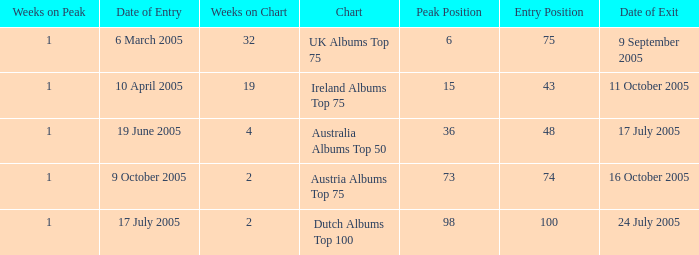Would you be able to parse every entry in this table? {'header': ['Weeks on Peak', 'Date of Entry', 'Weeks on Chart', 'Chart', 'Peak Position', 'Entry Position', 'Date of Exit'], 'rows': [['1', '6 March 2005', '32', 'UK Albums Top 75', '6', '75', '9 September 2005'], ['1', '10 April 2005', '19', 'Ireland Albums Top 75', '15', '43', '11 October 2005'], ['1', '19 June 2005', '4', 'Australia Albums Top 50', '36', '48', '17 July 2005'], ['1', '9 October 2005', '2', 'Austria Albums Top 75', '73', '74', '16 October 2005'], ['1', '17 July 2005', '2', 'Dutch Albums Top 100', '98', '100', '24 July 2005']]} What was the total number of weeks on peak for the Ireland Albums Top 75 chart? 1.0. 